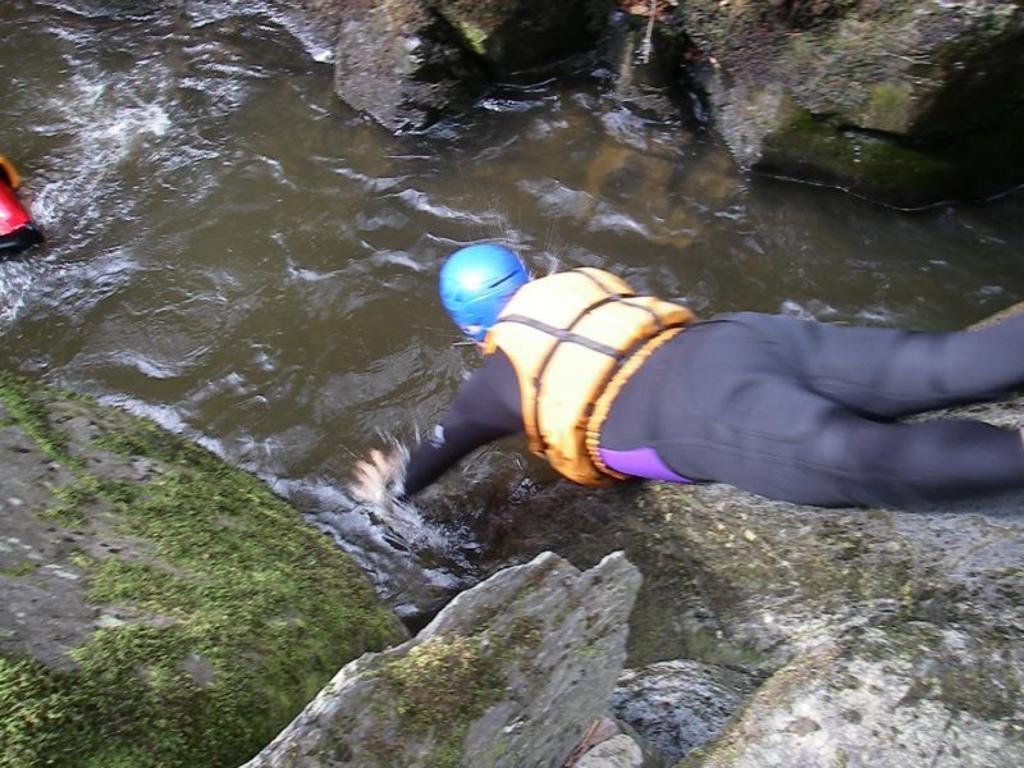Please provide a concise description of this image. In the image we can see there is a man laying. He is wearing a blue color helmet and there are rocks and the water are floating in between the rocks. 